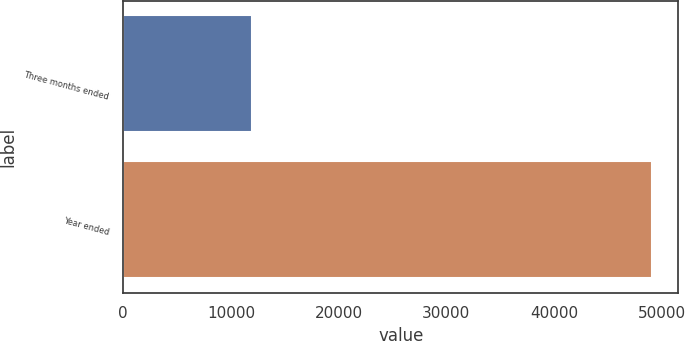<chart> <loc_0><loc_0><loc_500><loc_500><bar_chart><fcel>Three months ended<fcel>Year ended<nl><fcel>11959<fcel>49097<nl></chart> 